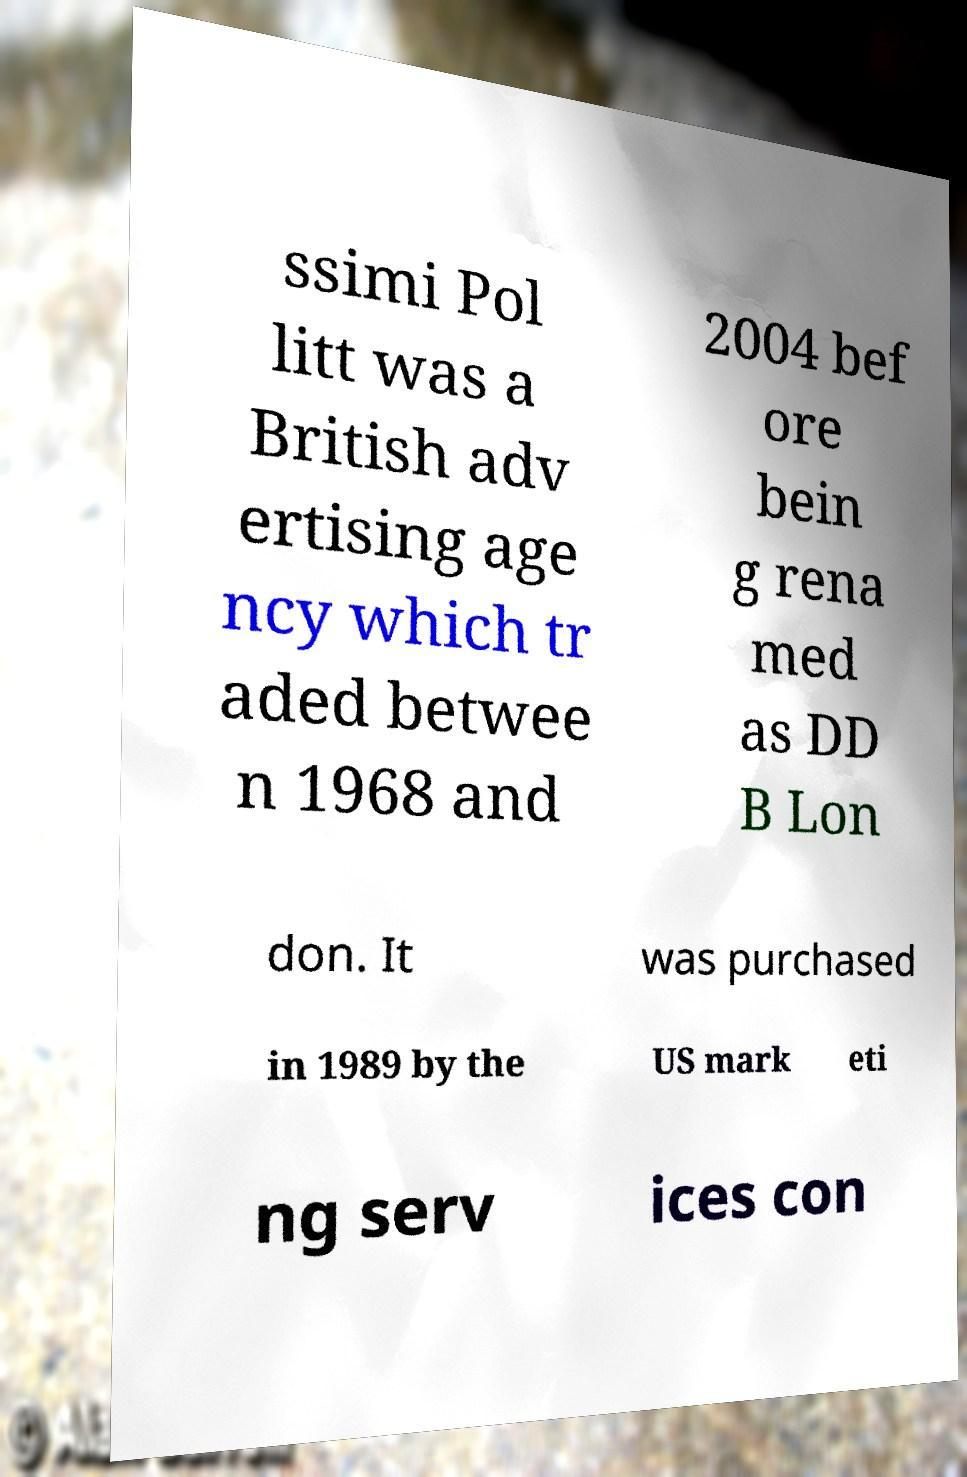For documentation purposes, I need the text within this image transcribed. Could you provide that? ssimi Pol litt was a British adv ertising age ncy which tr aded betwee n 1968 and 2004 bef ore bein g rena med as DD B Lon don. It was purchased in 1989 by the US mark eti ng serv ices con 